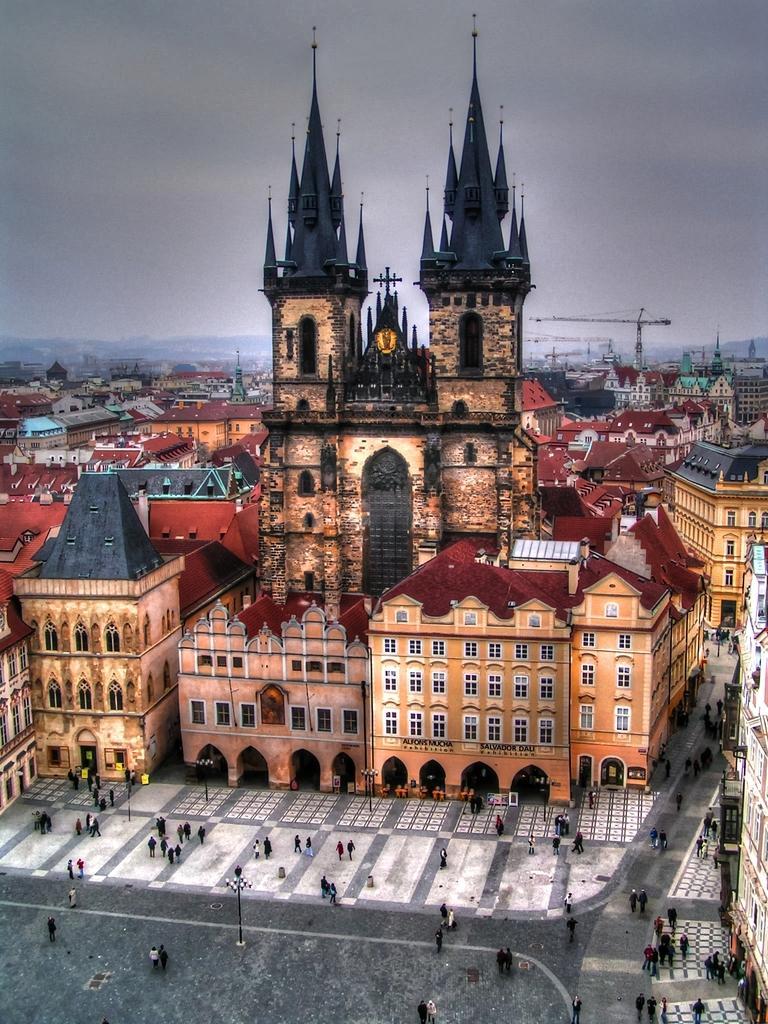Can you describe this image briefly? In this picture, we can see a few buildings, poles, cranes, a few people, ground, and the sky with clouds. 